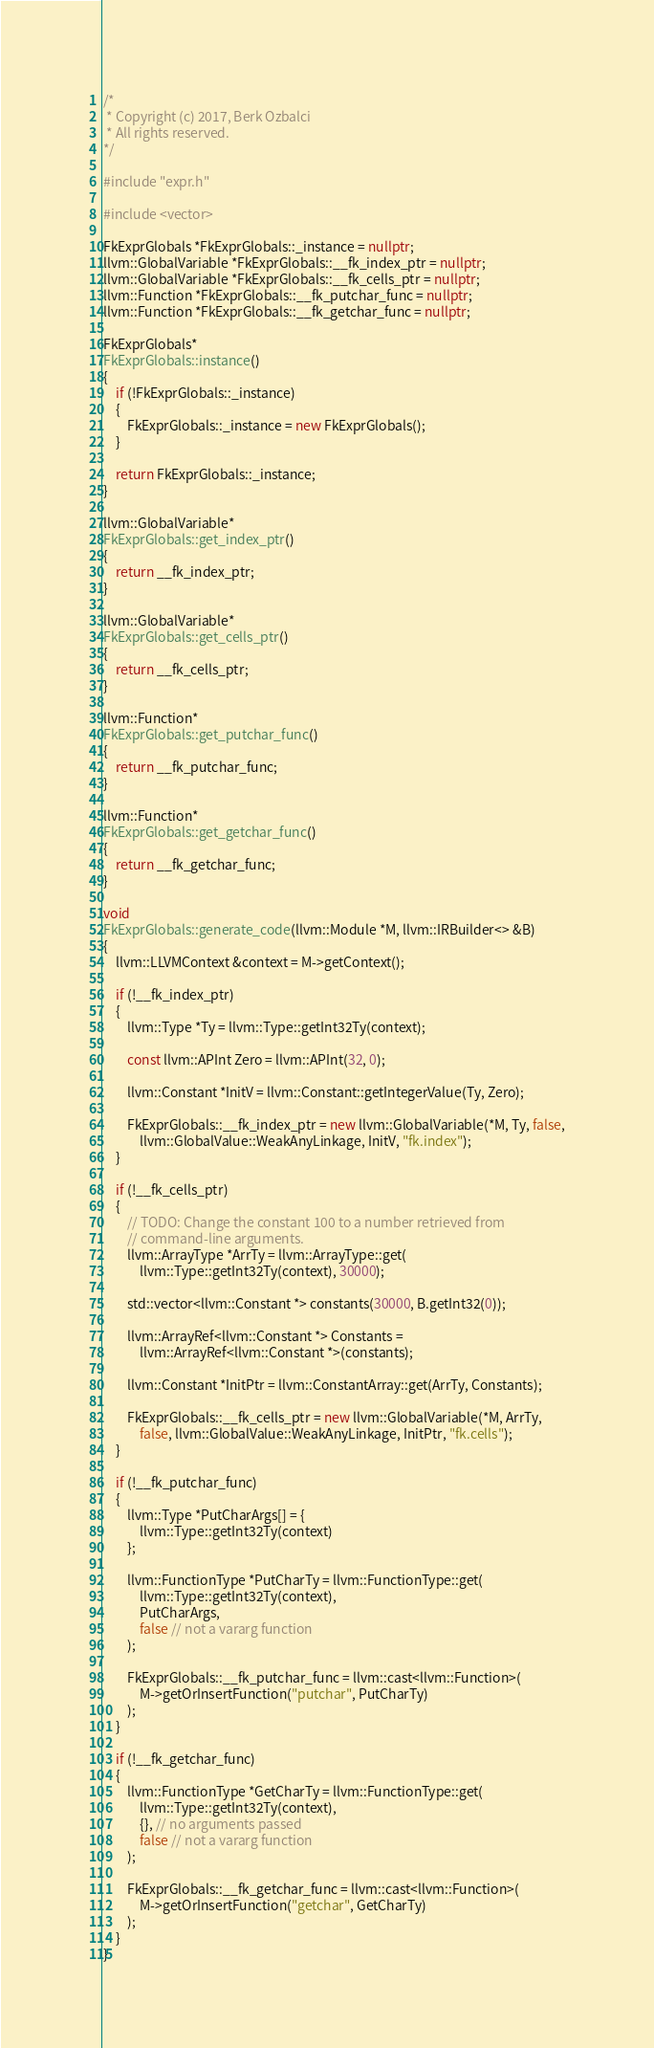<code> <loc_0><loc_0><loc_500><loc_500><_C++_>/*
 * Copyright (c) 2017, Berk Ozbalci
 * All rights reserved.
*/

#include "expr.h"

#include <vector>

FkExprGlobals *FkExprGlobals::_instance = nullptr;
llvm::GlobalVariable *FkExprGlobals::__fk_index_ptr = nullptr;
llvm::GlobalVariable *FkExprGlobals::__fk_cells_ptr = nullptr;
llvm::Function *FkExprGlobals::__fk_putchar_func = nullptr;
llvm::Function *FkExprGlobals::__fk_getchar_func = nullptr;

FkExprGlobals*
FkExprGlobals::instance()
{
    if (!FkExprGlobals::_instance)
    {
        FkExprGlobals::_instance = new FkExprGlobals();
    }

    return FkExprGlobals::_instance;
}

llvm::GlobalVariable*
FkExprGlobals::get_index_ptr()
{
    return __fk_index_ptr;
}

llvm::GlobalVariable*
FkExprGlobals::get_cells_ptr()
{
    return __fk_cells_ptr;
}

llvm::Function*
FkExprGlobals::get_putchar_func()
{
    return __fk_putchar_func;
}

llvm::Function*
FkExprGlobals::get_getchar_func()
{
    return __fk_getchar_func;
}

void
FkExprGlobals::generate_code(llvm::Module *M, llvm::IRBuilder<> &B)
{
    llvm::LLVMContext &context = M->getContext();

    if (!__fk_index_ptr)
    {
        llvm::Type *Ty = llvm::Type::getInt32Ty(context);

        const llvm::APInt Zero = llvm::APInt(32, 0);

        llvm::Constant *InitV = llvm::Constant::getIntegerValue(Ty, Zero);

        FkExprGlobals::__fk_index_ptr = new llvm::GlobalVariable(*M, Ty, false,
            llvm::GlobalValue::WeakAnyLinkage, InitV, "fk.index");
    }
    
    if (!__fk_cells_ptr)
    {
        // TODO: Change the constant 100 to a number retrieved from
        // command-line arguments.
        llvm::ArrayType *ArrTy = llvm::ArrayType::get(
            llvm::Type::getInt32Ty(context), 30000);

        std::vector<llvm::Constant *> constants(30000, B.getInt32(0));

        llvm::ArrayRef<llvm::Constant *> Constants =
            llvm::ArrayRef<llvm::Constant *>(constants);

        llvm::Constant *InitPtr = llvm::ConstantArray::get(ArrTy, Constants);

        FkExprGlobals::__fk_cells_ptr = new llvm::GlobalVariable(*M, ArrTy,
            false, llvm::GlobalValue::WeakAnyLinkage, InitPtr, "fk.cells");
    }

    if (!__fk_putchar_func)
    {
        llvm::Type *PutCharArgs[] = {
            llvm::Type::getInt32Ty(context)
        };

        llvm::FunctionType *PutCharTy = llvm::FunctionType::get(
            llvm::Type::getInt32Ty(context),
            PutCharArgs,
            false // not a vararg function
        );

        FkExprGlobals::__fk_putchar_func = llvm::cast<llvm::Function>(
            M->getOrInsertFunction("putchar", PutCharTy)
        );
    }
    
    if (!__fk_getchar_func)
    {
        llvm::FunctionType *GetCharTy = llvm::FunctionType::get(
            llvm::Type::getInt32Ty(context),
            {}, // no arguments passed
            false // not a vararg function
        );

        FkExprGlobals::__fk_getchar_func = llvm::cast<llvm::Function>(
            M->getOrInsertFunction("getchar", GetCharTy)
        );
    }
}
</code> 